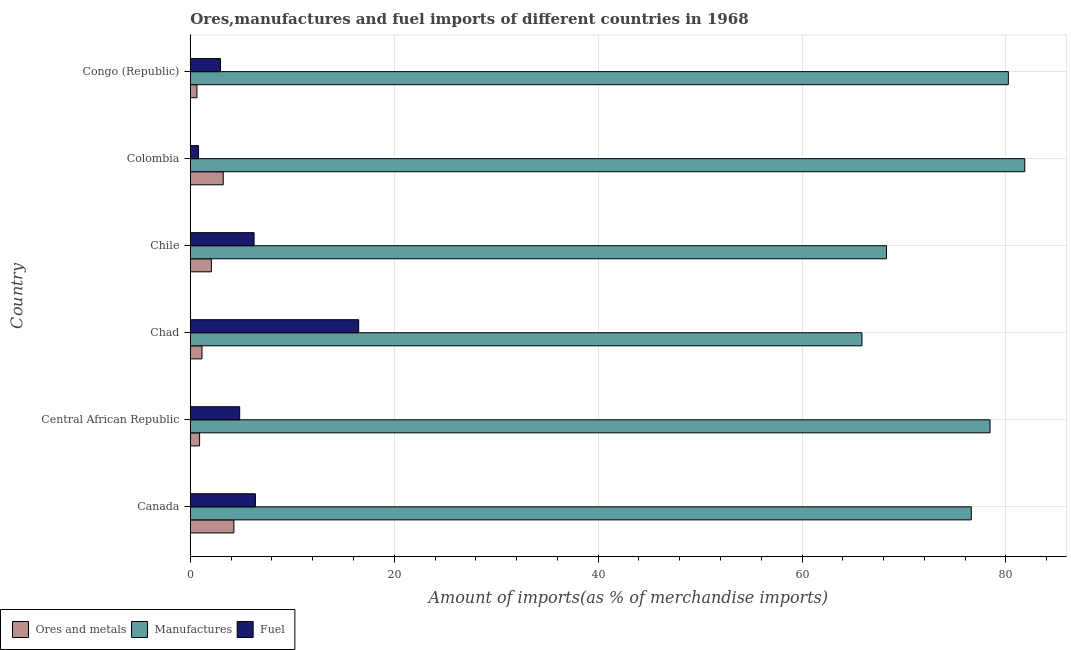How many groups of bars are there?
Your answer should be very brief. 6. Are the number of bars per tick equal to the number of legend labels?
Offer a very short reply. Yes. What is the percentage of manufactures imports in Chile?
Make the answer very short. 68.28. Across all countries, what is the maximum percentage of ores and metals imports?
Offer a very short reply. 4.27. Across all countries, what is the minimum percentage of manufactures imports?
Give a very brief answer. 65.87. In which country was the percentage of ores and metals imports minimum?
Make the answer very short. Congo (Republic). What is the total percentage of fuel imports in the graph?
Provide a succinct answer. 37.77. What is the difference between the percentage of fuel imports in Central African Republic and that in Chile?
Your answer should be compact. -1.41. What is the difference between the percentage of fuel imports in Chad and the percentage of ores and metals imports in Chile?
Ensure brevity in your answer.  14.45. What is the average percentage of manufactures imports per country?
Ensure brevity in your answer.  75.21. What is the difference between the percentage of manufactures imports and percentage of ores and metals imports in Central African Republic?
Provide a short and direct response. 77.52. What is the ratio of the percentage of ores and metals imports in Chile to that in Colombia?
Give a very brief answer. 0.64. Is the percentage of ores and metals imports in Canada less than that in Congo (Republic)?
Provide a succinct answer. No. Is the difference between the percentage of ores and metals imports in Chad and Chile greater than the difference between the percentage of manufactures imports in Chad and Chile?
Keep it short and to the point. Yes. What is the difference between the highest and the second highest percentage of manufactures imports?
Give a very brief answer. 1.61. What is the difference between the highest and the lowest percentage of manufactures imports?
Your answer should be compact. 15.97. In how many countries, is the percentage of manufactures imports greater than the average percentage of manufactures imports taken over all countries?
Provide a succinct answer. 4. What does the 3rd bar from the top in Chile represents?
Offer a terse response. Ores and metals. What does the 3rd bar from the bottom in Central African Republic represents?
Provide a succinct answer. Fuel. Is it the case that in every country, the sum of the percentage of ores and metals imports and percentage of manufactures imports is greater than the percentage of fuel imports?
Ensure brevity in your answer.  Yes. How many bars are there?
Keep it short and to the point. 18. How many countries are there in the graph?
Offer a very short reply. 6. Are the values on the major ticks of X-axis written in scientific E-notation?
Your answer should be compact. No. Does the graph contain grids?
Provide a short and direct response. Yes. What is the title of the graph?
Ensure brevity in your answer.  Ores,manufactures and fuel imports of different countries in 1968. What is the label or title of the X-axis?
Provide a short and direct response. Amount of imports(as % of merchandise imports). What is the label or title of the Y-axis?
Offer a very short reply. Country. What is the Amount of imports(as % of merchandise imports) of Ores and metals in Canada?
Ensure brevity in your answer.  4.27. What is the Amount of imports(as % of merchandise imports) in Manufactures in Canada?
Offer a terse response. 76.6. What is the Amount of imports(as % of merchandise imports) of Fuel in Canada?
Your answer should be compact. 6.39. What is the Amount of imports(as % of merchandise imports) in Ores and metals in Central African Republic?
Your answer should be compact. 0.91. What is the Amount of imports(as % of merchandise imports) of Manufactures in Central African Republic?
Provide a succinct answer. 78.44. What is the Amount of imports(as % of merchandise imports) in Fuel in Central African Republic?
Offer a very short reply. 4.84. What is the Amount of imports(as % of merchandise imports) in Ores and metals in Chad?
Offer a terse response. 1.14. What is the Amount of imports(as % of merchandise imports) of Manufactures in Chad?
Keep it short and to the point. 65.87. What is the Amount of imports(as % of merchandise imports) in Fuel in Chad?
Offer a terse response. 16.52. What is the Amount of imports(as % of merchandise imports) of Ores and metals in Chile?
Your answer should be compact. 2.07. What is the Amount of imports(as % of merchandise imports) of Manufactures in Chile?
Give a very brief answer. 68.28. What is the Amount of imports(as % of merchandise imports) of Fuel in Chile?
Offer a terse response. 6.26. What is the Amount of imports(as % of merchandise imports) in Ores and metals in Colombia?
Make the answer very short. 3.23. What is the Amount of imports(as % of merchandise imports) of Manufactures in Colombia?
Offer a terse response. 81.84. What is the Amount of imports(as % of merchandise imports) of Fuel in Colombia?
Your response must be concise. 0.81. What is the Amount of imports(as % of merchandise imports) in Ores and metals in Congo (Republic)?
Offer a very short reply. 0.65. What is the Amount of imports(as % of merchandise imports) in Manufactures in Congo (Republic)?
Ensure brevity in your answer.  80.23. What is the Amount of imports(as % of merchandise imports) of Fuel in Congo (Republic)?
Your answer should be very brief. 2.96. Across all countries, what is the maximum Amount of imports(as % of merchandise imports) of Ores and metals?
Keep it short and to the point. 4.27. Across all countries, what is the maximum Amount of imports(as % of merchandise imports) of Manufactures?
Your response must be concise. 81.84. Across all countries, what is the maximum Amount of imports(as % of merchandise imports) of Fuel?
Offer a very short reply. 16.52. Across all countries, what is the minimum Amount of imports(as % of merchandise imports) of Ores and metals?
Keep it short and to the point. 0.65. Across all countries, what is the minimum Amount of imports(as % of merchandise imports) in Manufactures?
Provide a short and direct response. 65.87. Across all countries, what is the minimum Amount of imports(as % of merchandise imports) in Fuel?
Provide a succinct answer. 0.81. What is the total Amount of imports(as % of merchandise imports) of Ores and metals in the graph?
Make the answer very short. 12.28. What is the total Amount of imports(as % of merchandise imports) of Manufactures in the graph?
Make the answer very short. 451.26. What is the total Amount of imports(as % of merchandise imports) of Fuel in the graph?
Provide a short and direct response. 37.77. What is the difference between the Amount of imports(as % of merchandise imports) of Ores and metals in Canada and that in Central African Republic?
Provide a short and direct response. 3.36. What is the difference between the Amount of imports(as % of merchandise imports) of Manufactures in Canada and that in Central African Republic?
Offer a terse response. -1.84. What is the difference between the Amount of imports(as % of merchandise imports) in Fuel in Canada and that in Central African Republic?
Ensure brevity in your answer.  1.54. What is the difference between the Amount of imports(as % of merchandise imports) in Ores and metals in Canada and that in Chad?
Make the answer very short. 3.13. What is the difference between the Amount of imports(as % of merchandise imports) of Manufactures in Canada and that in Chad?
Provide a succinct answer. 10.72. What is the difference between the Amount of imports(as % of merchandise imports) of Fuel in Canada and that in Chad?
Provide a succinct answer. -10.13. What is the difference between the Amount of imports(as % of merchandise imports) of Ores and metals in Canada and that in Chile?
Keep it short and to the point. 2.21. What is the difference between the Amount of imports(as % of merchandise imports) of Manufactures in Canada and that in Chile?
Provide a succinct answer. 8.32. What is the difference between the Amount of imports(as % of merchandise imports) in Fuel in Canada and that in Chile?
Your answer should be compact. 0.13. What is the difference between the Amount of imports(as % of merchandise imports) in Ores and metals in Canada and that in Colombia?
Provide a short and direct response. 1.04. What is the difference between the Amount of imports(as % of merchandise imports) of Manufactures in Canada and that in Colombia?
Make the answer very short. -5.24. What is the difference between the Amount of imports(as % of merchandise imports) in Fuel in Canada and that in Colombia?
Your answer should be very brief. 5.58. What is the difference between the Amount of imports(as % of merchandise imports) of Ores and metals in Canada and that in Congo (Republic)?
Your answer should be compact. 3.62. What is the difference between the Amount of imports(as % of merchandise imports) of Manufactures in Canada and that in Congo (Republic)?
Offer a very short reply. -3.63. What is the difference between the Amount of imports(as % of merchandise imports) in Fuel in Canada and that in Congo (Republic)?
Ensure brevity in your answer.  3.42. What is the difference between the Amount of imports(as % of merchandise imports) of Ores and metals in Central African Republic and that in Chad?
Provide a short and direct response. -0.23. What is the difference between the Amount of imports(as % of merchandise imports) in Manufactures in Central African Republic and that in Chad?
Provide a short and direct response. 12.56. What is the difference between the Amount of imports(as % of merchandise imports) in Fuel in Central African Republic and that in Chad?
Provide a short and direct response. -11.67. What is the difference between the Amount of imports(as % of merchandise imports) of Ores and metals in Central African Republic and that in Chile?
Your answer should be very brief. -1.15. What is the difference between the Amount of imports(as % of merchandise imports) of Manufactures in Central African Republic and that in Chile?
Provide a short and direct response. 10.16. What is the difference between the Amount of imports(as % of merchandise imports) in Fuel in Central African Republic and that in Chile?
Keep it short and to the point. -1.41. What is the difference between the Amount of imports(as % of merchandise imports) of Ores and metals in Central African Republic and that in Colombia?
Make the answer very short. -2.32. What is the difference between the Amount of imports(as % of merchandise imports) of Manufactures in Central African Republic and that in Colombia?
Your response must be concise. -3.41. What is the difference between the Amount of imports(as % of merchandise imports) of Fuel in Central African Republic and that in Colombia?
Offer a very short reply. 4.04. What is the difference between the Amount of imports(as % of merchandise imports) in Ores and metals in Central African Republic and that in Congo (Republic)?
Give a very brief answer. 0.26. What is the difference between the Amount of imports(as % of merchandise imports) of Manufactures in Central African Republic and that in Congo (Republic)?
Your answer should be very brief. -1.79. What is the difference between the Amount of imports(as % of merchandise imports) in Fuel in Central African Republic and that in Congo (Republic)?
Provide a short and direct response. 1.88. What is the difference between the Amount of imports(as % of merchandise imports) in Ores and metals in Chad and that in Chile?
Your response must be concise. -0.92. What is the difference between the Amount of imports(as % of merchandise imports) in Manufactures in Chad and that in Chile?
Give a very brief answer. -2.4. What is the difference between the Amount of imports(as % of merchandise imports) in Fuel in Chad and that in Chile?
Provide a succinct answer. 10.26. What is the difference between the Amount of imports(as % of merchandise imports) in Ores and metals in Chad and that in Colombia?
Make the answer very short. -2.09. What is the difference between the Amount of imports(as % of merchandise imports) of Manufactures in Chad and that in Colombia?
Keep it short and to the point. -15.97. What is the difference between the Amount of imports(as % of merchandise imports) in Fuel in Chad and that in Colombia?
Ensure brevity in your answer.  15.71. What is the difference between the Amount of imports(as % of merchandise imports) of Ores and metals in Chad and that in Congo (Republic)?
Provide a succinct answer. 0.49. What is the difference between the Amount of imports(as % of merchandise imports) in Manufactures in Chad and that in Congo (Republic)?
Offer a very short reply. -14.36. What is the difference between the Amount of imports(as % of merchandise imports) in Fuel in Chad and that in Congo (Republic)?
Your answer should be compact. 13.55. What is the difference between the Amount of imports(as % of merchandise imports) of Ores and metals in Chile and that in Colombia?
Give a very brief answer. -1.16. What is the difference between the Amount of imports(as % of merchandise imports) of Manufactures in Chile and that in Colombia?
Provide a short and direct response. -13.56. What is the difference between the Amount of imports(as % of merchandise imports) of Fuel in Chile and that in Colombia?
Provide a succinct answer. 5.45. What is the difference between the Amount of imports(as % of merchandise imports) of Ores and metals in Chile and that in Congo (Republic)?
Ensure brevity in your answer.  1.42. What is the difference between the Amount of imports(as % of merchandise imports) in Manufactures in Chile and that in Congo (Republic)?
Provide a short and direct response. -11.95. What is the difference between the Amount of imports(as % of merchandise imports) in Fuel in Chile and that in Congo (Republic)?
Your response must be concise. 3.29. What is the difference between the Amount of imports(as % of merchandise imports) in Ores and metals in Colombia and that in Congo (Republic)?
Make the answer very short. 2.58. What is the difference between the Amount of imports(as % of merchandise imports) of Manufactures in Colombia and that in Congo (Republic)?
Give a very brief answer. 1.61. What is the difference between the Amount of imports(as % of merchandise imports) in Fuel in Colombia and that in Congo (Republic)?
Provide a short and direct response. -2.16. What is the difference between the Amount of imports(as % of merchandise imports) of Ores and metals in Canada and the Amount of imports(as % of merchandise imports) of Manufactures in Central African Republic?
Offer a terse response. -74.16. What is the difference between the Amount of imports(as % of merchandise imports) in Ores and metals in Canada and the Amount of imports(as % of merchandise imports) in Fuel in Central African Republic?
Offer a terse response. -0.57. What is the difference between the Amount of imports(as % of merchandise imports) in Manufactures in Canada and the Amount of imports(as % of merchandise imports) in Fuel in Central African Republic?
Ensure brevity in your answer.  71.75. What is the difference between the Amount of imports(as % of merchandise imports) in Ores and metals in Canada and the Amount of imports(as % of merchandise imports) in Manufactures in Chad?
Give a very brief answer. -61.6. What is the difference between the Amount of imports(as % of merchandise imports) in Ores and metals in Canada and the Amount of imports(as % of merchandise imports) in Fuel in Chad?
Make the answer very short. -12.24. What is the difference between the Amount of imports(as % of merchandise imports) of Manufactures in Canada and the Amount of imports(as % of merchandise imports) of Fuel in Chad?
Offer a terse response. 60.08. What is the difference between the Amount of imports(as % of merchandise imports) in Ores and metals in Canada and the Amount of imports(as % of merchandise imports) in Manufactures in Chile?
Offer a terse response. -64. What is the difference between the Amount of imports(as % of merchandise imports) in Ores and metals in Canada and the Amount of imports(as % of merchandise imports) in Fuel in Chile?
Your answer should be very brief. -1.98. What is the difference between the Amount of imports(as % of merchandise imports) in Manufactures in Canada and the Amount of imports(as % of merchandise imports) in Fuel in Chile?
Your answer should be compact. 70.34. What is the difference between the Amount of imports(as % of merchandise imports) of Ores and metals in Canada and the Amount of imports(as % of merchandise imports) of Manufactures in Colombia?
Keep it short and to the point. -77.57. What is the difference between the Amount of imports(as % of merchandise imports) of Ores and metals in Canada and the Amount of imports(as % of merchandise imports) of Fuel in Colombia?
Give a very brief answer. 3.47. What is the difference between the Amount of imports(as % of merchandise imports) of Manufactures in Canada and the Amount of imports(as % of merchandise imports) of Fuel in Colombia?
Provide a short and direct response. 75.79. What is the difference between the Amount of imports(as % of merchandise imports) in Ores and metals in Canada and the Amount of imports(as % of merchandise imports) in Manufactures in Congo (Republic)?
Provide a short and direct response. -75.96. What is the difference between the Amount of imports(as % of merchandise imports) in Ores and metals in Canada and the Amount of imports(as % of merchandise imports) in Fuel in Congo (Republic)?
Keep it short and to the point. 1.31. What is the difference between the Amount of imports(as % of merchandise imports) of Manufactures in Canada and the Amount of imports(as % of merchandise imports) of Fuel in Congo (Republic)?
Your answer should be very brief. 73.63. What is the difference between the Amount of imports(as % of merchandise imports) in Ores and metals in Central African Republic and the Amount of imports(as % of merchandise imports) in Manufactures in Chad?
Provide a succinct answer. -64.96. What is the difference between the Amount of imports(as % of merchandise imports) in Ores and metals in Central African Republic and the Amount of imports(as % of merchandise imports) in Fuel in Chad?
Provide a succinct answer. -15.6. What is the difference between the Amount of imports(as % of merchandise imports) of Manufactures in Central African Republic and the Amount of imports(as % of merchandise imports) of Fuel in Chad?
Your answer should be very brief. 61.92. What is the difference between the Amount of imports(as % of merchandise imports) in Ores and metals in Central African Republic and the Amount of imports(as % of merchandise imports) in Manufactures in Chile?
Keep it short and to the point. -67.37. What is the difference between the Amount of imports(as % of merchandise imports) in Ores and metals in Central African Republic and the Amount of imports(as % of merchandise imports) in Fuel in Chile?
Make the answer very short. -5.34. What is the difference between the Amount of imports(as % of merchandise imports) of Manufactures in Central African Republic and the Amount of imports(as % of merchandise imports) of Fuel in Chile?
Offer a terse response. 72.18. What is the difference between the Amount of imports(as % of merchandise imports) of Ores and metals in Central African Republic and the Amount of imports(as % of merchandise imports) of Manufactures in Colombia?
Provide a short and direct response. -80.93. What is the difference between the Amount of imports(as % of merchandise imports) of Ores and metals in Central African Republic and the Amount of imports(as % of merchandise imports) of Fuel in Colombia?
Provide a short and direct response. 0.11. What is the difference between the Amount of imports(as % of merchandise imports) of Manufactures in Central African Republic and the Amount of imports(as % of merchandise imports) of Fuel in Colombia?
Your answer should be compact. 77.63. What is the difference between the Amount of imports(as % of merchandise imports) of Ores and metals in Central African Republic and the Amount of imports(as % of merchandise imports) of Manufactures in Congo (Republic)?
Keep it short and to the point. -79.32. What is the difference between the Amount of imports(as % of merchandise imports) in Ores and metals in Central African Republic and the Amount of imports(as % of merchandise imports) in Fuel in Congo (Republic)?
Your answer should be very brief. -2.05. What is the difference between the Amount of imports(as % of merchandise imports) of Manufactures in Central African Republic and the Amount of imports(as % of merchandise imports) of Fuel in Congo (Republic)?
Give a very brief answer. 75.47. What is the difference between the Amount of imports(as % of merchandise imports) in Ores and metals in Chad and the Amount of imports(as % of merchandise imports) in Manufactures in Chile?
Give a very brief answer. -67.13. What is the difference between the Amount of imports(as % of merchandise imports) of Ores and metals in Chad and the Amount of imports(as % of merchandise imports) of Fuel in Chile?
Your answer should be compact. -5.11. What is the difference between the Amount of imports(as % of merchandise imports) of Manufactures in Chad and the Amount of imports(as % of merchandise imports) of Fuel in Chile?
Your answer should be compact. 59.62. What is the difference between the Amount of imports(as % of merchandise imports) of Ores and metals in Chad and the Amount of imports(as % of merchandise imports) of Manufactures in Colombia?
Offer a very short reply. -80.7. What is the difference between the Amount of imports(as % of merchandise imports) in Ores and metals in Chad and the Amount of imports(as % of merchandise imports) in Fuel in Colombia?
Your answer should be compact. 0.34. What is the difference between the Amount of imports(as % of merchandise imports) in Manufactures in Chad and the Amount of imports(as % of merchandise imports) in Fuel in Colombia?
Provide a short and direct response. 65.07. What is the difference between the Amount of imports(as % of merchandise imports) of Ores and metals in Chad and the Amount of imports(as % of merchandise imports) of Manufactures in Congo (Republic)?
Keep it short and to the point. -79.09. What is the difference between the Amount of imports(as % of merchandise imports) of Ores and metals in Chad and the Amount of imports(as % of merchandise imports) of Fuel in Congo (Republic)?
Give a very brief answer. -1.82. What is the difference between the Amount of imports(as % of merchandise imports) of Manufactures in Chad and the Amount of imports(as % of merchandise imports) of Fuel in Congo (Republic)?
Offer a very short reply. 62.91. What is the difference between the Amount of imports(as % of merchandise imports) in Ores and metals in Chile and the Amount of imports(as % of merchandise imports) in Manufactures in Colombia?
Your response must be concise. -79.77. What is the difference between the Amount of imports(as % of merchandise imports) of Ores and metals in Chile and the Amount of imports(as % of merchandise imports) of Fuel in Colombia?
Make the answer very short. 1.26. What is the difference between the Amount of imports(as % of merchandise imports) in Manufactures in Chile and the Amount of imports(as % of merchandise imports) in Fuel in Colombia?
Your answer should be compact. 67.47. What is the difference between the Amount of imports(as % of merchandise imports) of Ores and metals in Chile and the Amount of imports(as % of merchandise imports) of Manufactures in Congo (Republic)?
Your answer should be very brief. -78.16. What is the difference between the Amount of imports(as % of merchandise imports) in Ores and metals in Chile and the Amount of imports(as % of merchandise imports) in Fuel in Congo (Republic)?
Your response must be concise. -0.9. What is the difference between the Amount of imports(as % of merchandise imports) of Manufactures in Chile and the Amount of imports(as % of merchandise imports) of Fuel in Congo (Republic)?
Your answer should be very brief. 65.31. What is the difference between the Amount of imports(as % of merchandise imports) in Ores and metals in Colombia and the Amount of imports(as % of merchandise imports) in Manufactures in Congo (Republic)?
Offer a terse response. -77. What is the difference between the Amount of imports(as % of merchandise imports) in Ores and metals in Colombia and the Amount of imports(as % of merchandise imports) in Fuel in Congo (Republic)?
Ensure brevity in your answer.  0.27. What is the difference between the Amount of imports(as % of merchandise imports) in Manufactures in Colombia and the Amount of imports(as % of merchandise imports) in Fuel in Congo (Republic)?
Ensure brevity in your answer.  78.88. What is the average Amount of imports(as % of merchandise imports) of Ores and metals per country?
Make the answer very short. 2.05. What is the average Amount of imports(as % of merchandise imports) in Manufactures per country?
Keep it short and to the point. 75.21. What is the average Amount of imports(as % of merchandise imports) in Fuel per country?
Provide a short and direct response. 6.3. What is the difference between the Amount of imports(as % of merchandise imports) of Ores and metals and Amount of imports(as % of merchandise imports) of Manufactures in Canada?
Your answer should be very brief. -72.32. What is the difference between the Amount of imports(as % of merchandise imports) in Ores and metals and Amount of imports(as % of merchandise imports) in Fuel in Canada?
Provide a succinct answer. -2.11. What is the difference between the Amount of imports(as % of merchandise imports) in Manufactures and Amount of imports(as % of merchandise imports) in Fuel in Canada?
Give a very brief answer. 70.21. What is the difference between the Amount of imports(as % of merchandise imports) in Ores and metals and Amount of imports(as % of merchandise imports) in Manufactures in Central African Republic?
Provide a succinct answer. -77.52. What is the difference between the Amount of imports(as % of merchandise imports) in Ores and metals and Amount of imports(as % of merchandise imports) in Fuel in Central African Republic?
Give a very brief answer. -3.93. What is the difference between the Amount of imports(as % of merchandise imports) in Manufactures and Amount of imports(as % of merchandise imports) in Fuel in Central African Republic?
Offer a very short reply. 73.59. What is the difference between the Amount of imports(as % of merchandise imports) of Ores and metals and Amount of imports(as % of merchandise imports) of Manufactures in Chad?
Your answer should be very brief. -64.73. What is the difference between the Amount of imports(as % of merchandise imports) of Ores and metals and Amount of imports(as % of merchandise imports) of Fuel in Chad?
Offer a very short reply. -15.37. What is the difference between the Amount of imports(as % of merchandise imports) of Manufactures and Amount of imports(as % of merchandise imports) of Fuel in Chad?
Make the answer very short. 49.36. What is the difference between the Amount of imports(as % of merchandise imports) of Ores and metals and Amount of imports(as % of merchandise imports) of Manufactures in Chile?
Your response must be concise. -66.21. What is the difference between the Amount of imports(as % of merchandise imports) in Ores and metals and Amount of imports(as % of merchandise imports) in Fuel in Chile?
Ensure brevity in your answer.  -4.19. What is the difference between the Amount of imports(as % of merchandise imports) in Manufactures and Amount of imports(as % of merchandise imports) in Fuel in Chile?
Ensure brevity in your answer.  62.02. What is the difference between the Amount of imports(as % of merchandise imports) in Ores and metals and Amount of imports(as % of merchandise imports) in Manufactures in Colombia?
Your answer should be very brief. -78.61. What is the difference between the Amount of imports(as % of merchandise imports) in Ores and metals and Amount of imports(as % of merchandise imports) in Fuel in Colombia?
Keep it short and to the point. 2.42. What is the difference between the Amount of imports(as % of merchandise imports) in Manufactures and Amount of imports(as % of merchandise imports) in Fuel in Colombia?
Provide a short and direct response. 81.04. What is the difference between the Amount of imports(as % of merchandise imports) of Ores and metals and Amount of imports(as % of merchandise imports) of Manufactures in Congo (Republic)?
Offer a terse response. -79.58. What is the difference between the Amount of imports(as % of merchandise imports) in Ores and metals and Amount of imports(as % of merchandise imports) in Fuel in Congo (Republic)?
Make the answer very short. -2.31. What is the difference between the Amount of imports(as % of merchandise imports) of Manufactures and Amount of imports(as % of merchandise imports) of Fuel in Congo (Republic)?
Give a very brief answer. 77.27. What is the ratio of the Amount of imports(as % of merchandise imports) of Ores and metals in Canada to that in Central African Republic?
Offer a very short reply. 4.68. What is the ratio of the Amount of imports(as % of merchandise imports) in Manufactures in Canada to that in Central African Republic?
Ensure brevity in your answer.  0.98. What is the ratio of the Amount of imports(as % of merchandise imports) in Fuel in Canada to that in Central African Republic?
Ensure brevity in your answer.  1.32. What is the ratio of the Amount of imports(as % of merchandise imports) of Ores and metals in Canada to that in Chad?
Ensure brevity in your answer.  3.74. What is the ratio of the Amount of imports(as % of merchandise imports) in Manufactures in Canada to that in Chad?
Offer a very short reply. 1.16. What is the ratio of the Amount of imports(as % of merchandise imports) in Fuel in Canada to that in Chad?
Provide a succinct answer. 0.39. What is the ratio of the Amount of imports(as % of merchandise imports) in Ores and metals in Canada to that in Chile?
Provide a succinct answer. 2.07. What is the ratio of the Amount of imports(as % of merchandise imports) in Manufactures in Canada to that in Chile?
Provide a short and direct response. 1.12. What is the ratio of the Amount of imports(as % of merchandise imports) in Fuel in Canada to that in Chile?
Keep it short and to the point. 1.02. What is the ratio of the Amount of imports(as % of merchandise imports) of Ores and metals in Canada to that in Colombia?
Make the answer very short. 1.32. What is the ratio of the Amount of imports(as % of merchandise imports) in Manufactures in Canada to that in Colombia?
Your answer should be compact. 0.94. What is the ratio of the Amount of imports(as % of merchandise imports) in Fuel in Canada to that in Colombia?
Your answer should be very brief. 7.91. What is the ratio of the Amount of imports(as % of merchandise imports) of Ores and metals in Canada to that in Congo (Republic)?
Your response must be concise. 6.56. What is the ratio of the Amount of imports(as % of merchandise imports) in Manufactures in Canada to that in Congo (Republic)?
Your response must be concise. 0.95. What is the ratio of the Amount of imports(as % of merchandise imports) of Fuel in Canada to that in Congo (Republic)?
Offer a very short reply. 2.15. What is the ratio of the Amount of imports(as % of merchandise imports) of Ores and metals in Central African Republic to that in Chad?
Provide a succinct answer. 0.8. What is the ratio of the Amount of imports(as % of merchandise imports) of Manufactures in Central African Republic to that in Chad?
Your response must be concise. 1.19. What is the ratio of the Amount of imports(as % of merchandise imports) of Fuel in Central African Republic to that in Chad?
Ensure brevity in your answer.  0.29. What is the ratio of the Amount of imports(as % of merchandise imports) in Ores and metals in Central African Republic to that in Chile?
Your answer should be very brief. 0.44. What is the ratio of the Amount of imports(as % of merchandise imports) in Manufactures in Central African Republic to that in Chile?
Ensure brevity in your answer.  1.15. What is the ratio of the Amount of imports(as % of merchandise imports) in Fuel in Central African Republic to that in Chile?
Ensure brevity in your answer.  0.77. What is the ratio of the Amount of imports(as % of merchandise imports) in Ores and metals in Central African Republic to that in Colombia?
Your answer should be very brief. 0.28. What is the ratio of the Amount of imports(as % of merchandise imports) in Manufactures in Central African Republic to that in Colombia?
Your response must be concise. 0.96. What is the ratio of the Amount of imports(as % of merchandise imports) of Fuel in Central African Republic to that in Colombia?
Provide a short and direct response. 6. What is the ratio of the Amount of imports(as % of merchandise imports) of Ores and metals in Central African Republic to that in Congo (Republic)?
Offer a terse response. 1.4. What is the ratio of the Amount of imports(as % of merchandise imports) in Manufactures in Central African Republic to that in Congo (Republic)?
Your answer should be very brief. 0.98. What is the ratio of the Amount of imports(as % of merchandise imports) of Fuel in Central African Republic to that in Congo (Republic)?
Give a very brief answer. 1.63. What is the ratio of the Amount of imports(as % of merchandise imports) in Ores and metals in Chad to that in Chile?
Ensure brevity in your answer.  0.55. What is the ratio of the Amount of imports(as % of merchandise imports) of Manufactures in Chad to that in Chile?
Offer a terse response. 0.96. What is the ratio of the Amount of imports(as % of merchandise imports) in Fuel in Chad to that in Chile?
Your answer should be very brief. 2.64. What is the ratio of the Amount of imports(as % of merchandise imports) in Ores and metals in Chad to that in Colombia?
Your response must be concise. 0.35. What is the ratio of the Amount of imports(as % of merchandise imports) of Manufactures in Chad to that in Colombia?
Make the answer very short. 0.8. What is the ratio of the Amount of imports(as % of merchandise imports) in Fuel in Chad to that in Colombia?
Offer a very short reply. 20.47. What is the ratio of the Amount of imports(as % of merchandise imports) in Ores and metals in Chad to that in Congo (Republic)?
Your response must be concise. 1.76. What is the ratio of the Amount of imports(as % of merchandise imports) in Manufactures in Chad to that in Congo (Republic)?
Make the answer very short. 0.82. What is the ratio of the Amount of imports(as % of merchandise imports) of Fuel in Chad to that in Congo (Republic)?
Keep it short and to the point. 5.57. What is the ratio of the Amount of imports(as % of merchandise imports) in Ores and metals in Chile to that in Colombia?
Provide a short and direct response. 0.64. What is the ratio of the Amount of imports(as % of merchandise imports) in Manufactures in Chile to that in Colombia?
Ensure brevity in your answer.  0.83. What is the ratio of the Amount of imports(as % of merchandise imports) of Fuel in Chile to that in Colombia?
Ensure brevity in your answer.  7.75. What is the ratio of the Amount of imports(as % of merchandise imports) of Ores and metals in Chile to that in Congo (Republic)?
Offer a terse response. 3.17. What is the ratio of the Amount of imports(as % of merchandise imports) of Manufactures in Chile to that in Congo (Republic)?
Give a very brief answer. 0.85. What is the ratio of the Amount of imports(as % of merchandise imports) of Fuel in Chile to that in Congo (Republic)?
Offer a very short reply. 2.11. What is the ratio of the Amount of imports(as % of merchandise imports) in Ores and metals in Colombia to that in Congo (Republic)?
Provide a succinct answer. 4.96. What is the ratio of the Amount of imports(as % of merchandise imports) in Manufactures in Colombia to that in Congo (Republic)?
Provide a succinct answer. 1.02. What is the ratio of the Amount of imports(as % of merchandise imports) in Fuel in Colombia to that in Congo (Republic)?
Offer a very short reply. 0.27. What is the difference between the highest and the second highest Amount of imports(as % of merchandise imports) of Ores and metals?
Keep it short and to the point. 1.04. What is the difference between the highest and the second highest Amount of imports(as % of merchandise imports) of Manufactures?
Make the answer very short. 1.61. What is the difference between the highest and the second highest Amount of imports(as % of merchandise imports) of Fuel?
Give a very brief answer. 10.13. What is the difference between the highest and the lowest Amount of imports(as % of merchandise imports) in Ores and metals?
Keep it short and to the point. 3.62. What is the difference between the highest and the lowest Amount of imports(as % of merchandise imports) of Manufactures?
Offer a very short reply. 15.97. What is the difference between the highest and the lowest Amount of imports(as % of merchandise imports) in Fuel?
Offer a terse response. 15.71. 